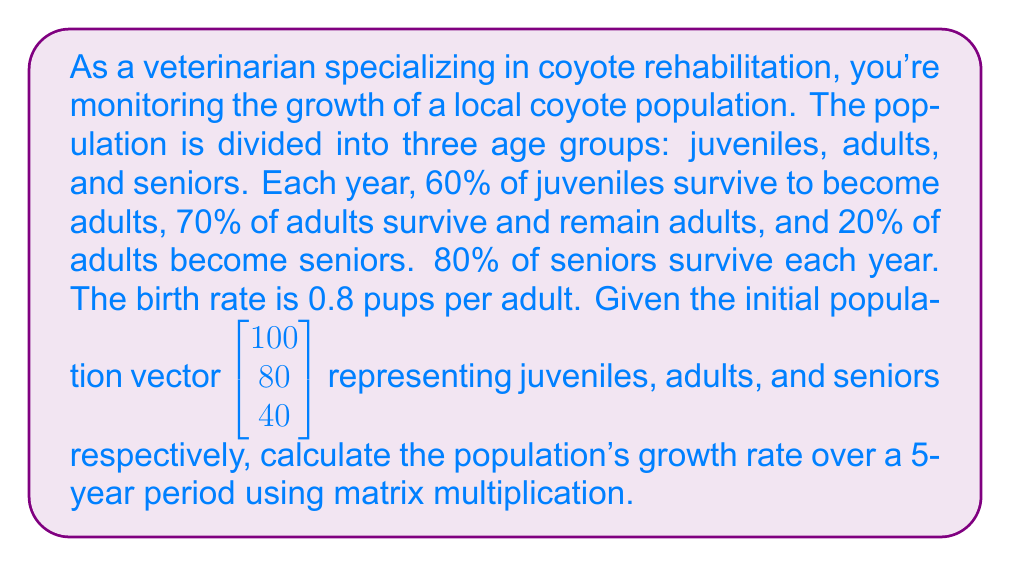Show me your answer to this math problem. 1. First, we need to construct the Leslie matrix based on the given information:

   $$A = \begin{bmatrix}
   0 & 0.8 & 0 \\
   0.6 & 0.7 & 0 \\
   0 & 0.2 & 0.8
   \end{bmatrix}$$

2. The initial population vector is:

   $$\vec{v}_0 = \begin{bmatrix} 100 \\ 80 \\ 40 \end{bmatrix}$$

3. To find the population after 5 years, we multiply the matrix A by itself 5 times and then multiply by the initial population vector:

   $$\vec{v}_5 = A^5 \cdot \vec{v}_0$$

4. Using a calculator or computer, we can compute $A^5$:

   $$A^5 \approx \begin{bmatrix}
   0.3949 & 0.8873 & 0.3549 \\
   0.4739 & 1.0648 & 0.4259 \\
   0.2615 & 0.5875 & 0.2350
   \end{bmatrix}$$

5. Now, we multiply $A^5$ by $\vec{v}_0$:

   $$\vec{v}_5 = \begin{bmatrix}
   0.3949 & 0.8873 & 0.3549 \\
   0.4739 & 1.0648 & 0.4259 \\
   0.2615 & 0.5875 & 0.2350
   \end{bmatrix} \cdot \begin{bmatrix} 100 \\ 80 \\ 40 \end{bmatrix}$$

6. Performing the multiplication:

   $$\vec{v}_5 \approx \begin{bmatrix} 145.3 \\ 174.4 \\ 96.2 \end{bmatrix}$$

7. To calculate the growth rate, we sum the total population at year 0 and year 5:

   Total at year 0: 100 + 80 + 40 = 220
   Total at year 5: 145.3 + 174.4 + 96.2 ≈ 415.9

8. The growth rate is calculated as:

   $$\text{Growth Rate} = \left(\frac{\text{Final Population}}{\text{Initial Population}}\right)^{\frac{1}{\text{Number of Years}}} - 1$$

   $$\text{Growth Rate} = \left(\frac{415.9}{220}\right)^{\frac{1}{5}} - 1 \approx 0.1357 \text{ or } 13.57\%$$
Answer: 13.57% 